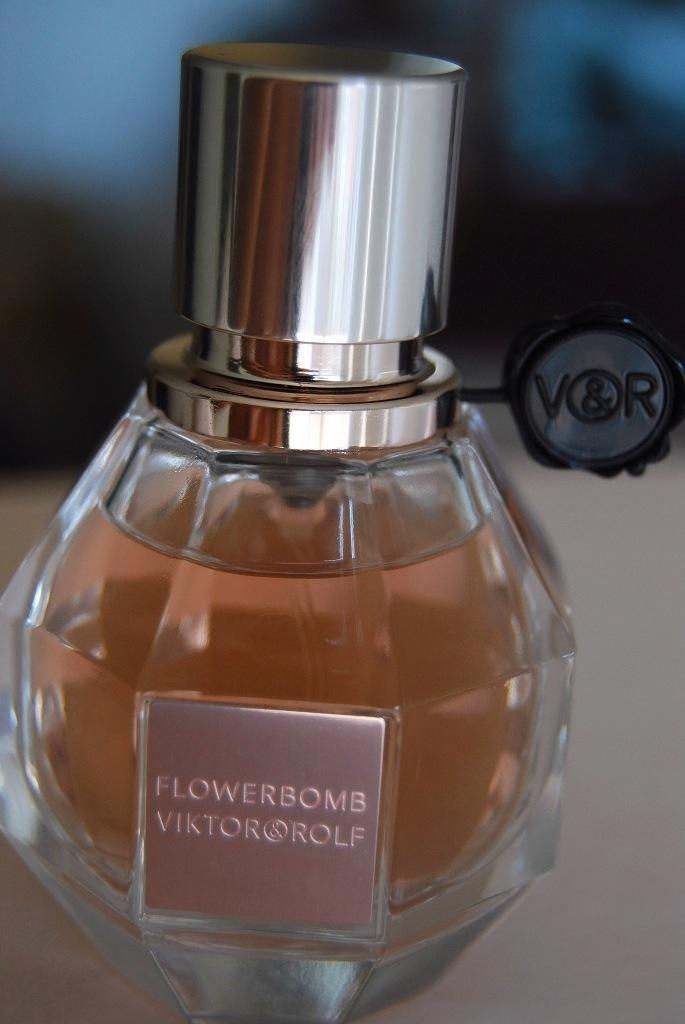Provide a one-sentence caption for the provided image. A perfume, made by Viktor & Rolf, is called Flowerbomb./. 